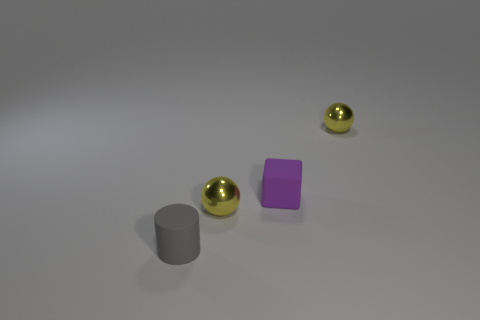What is the color of the metallic sphere that is left of the small matte thing on the right side of the small cylinder?
Make the answer very short. Yellow. How many tiny rubber blocks are there?
Offer a terse response. 1. How many tiny objects are on the left side of the tiny cube and right of the gray cylinder?
Offer a very short reply. 1. Is there anything else that has the same shape as the purple matte thing?
Your answer should be very brief. No. There is a tiny matte object that is on the left side of the tiny purple thing; what is its shape?
Keep it short and to the point. Cylinder. What number of other objects are there of the same material as the small purple object?
Keep it short and to the point. 1. How many big things are either yellow metal spheres or matte spheres?
Provide a succinct answer. 0. There is a tiny purple matte block; how many purple objects are in front of it?
Give a very brief answer. 0. Are there any metal things of the same color as the cylinder?
Offer a very short reply. No. What is the shape of the rubber thing that is the same size as the purple matte block?
Make the answer very short. Cylinder. 